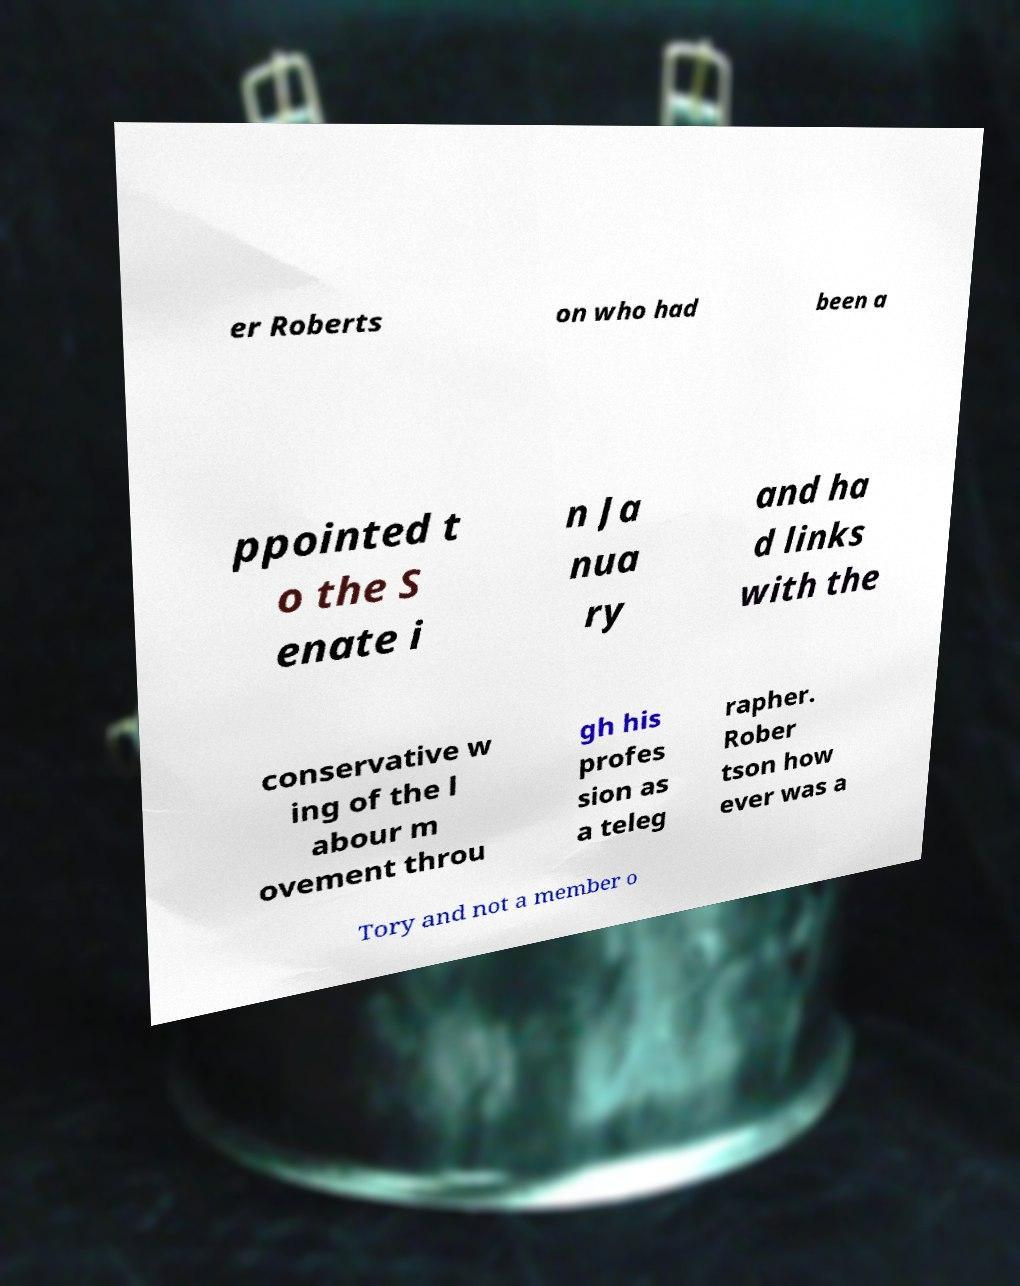I need the written content from this picture converted into text. Can you do that? er Roberts on who had been a ppointed t o the S enate i n Ja nua ry and ha d links with the conservative w ing of the l abour m ovement throu gh his profes sion as a teleg rapher. Rober tson how ever was a Tory and not a member o 